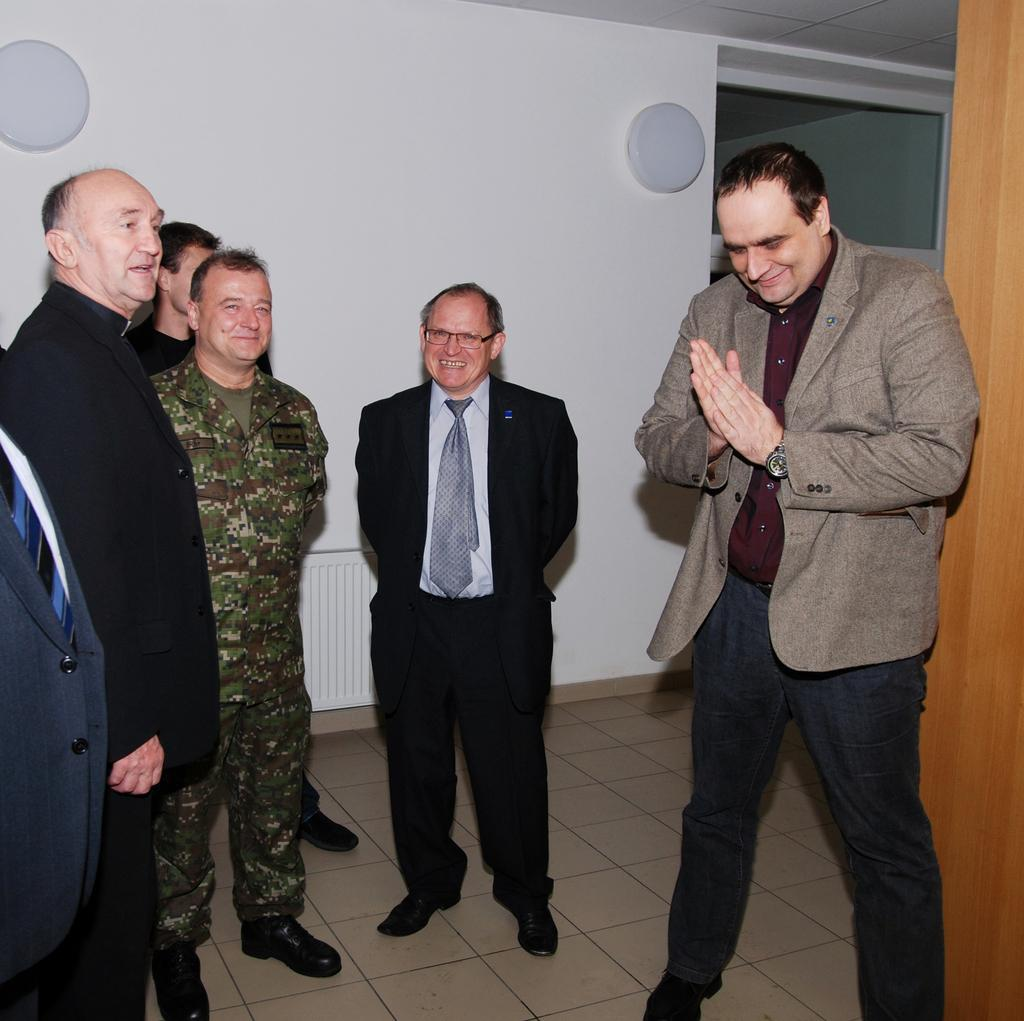What can you describe the people in the image? There are people standing in the image. What can be seen in the background of the image? There is a wall and a door in the background of the image. What type of fabric is the toothbrush made of in the image? There is no toothbrush present in the image, so it cannot be determined what type of fabric it might be made of. 